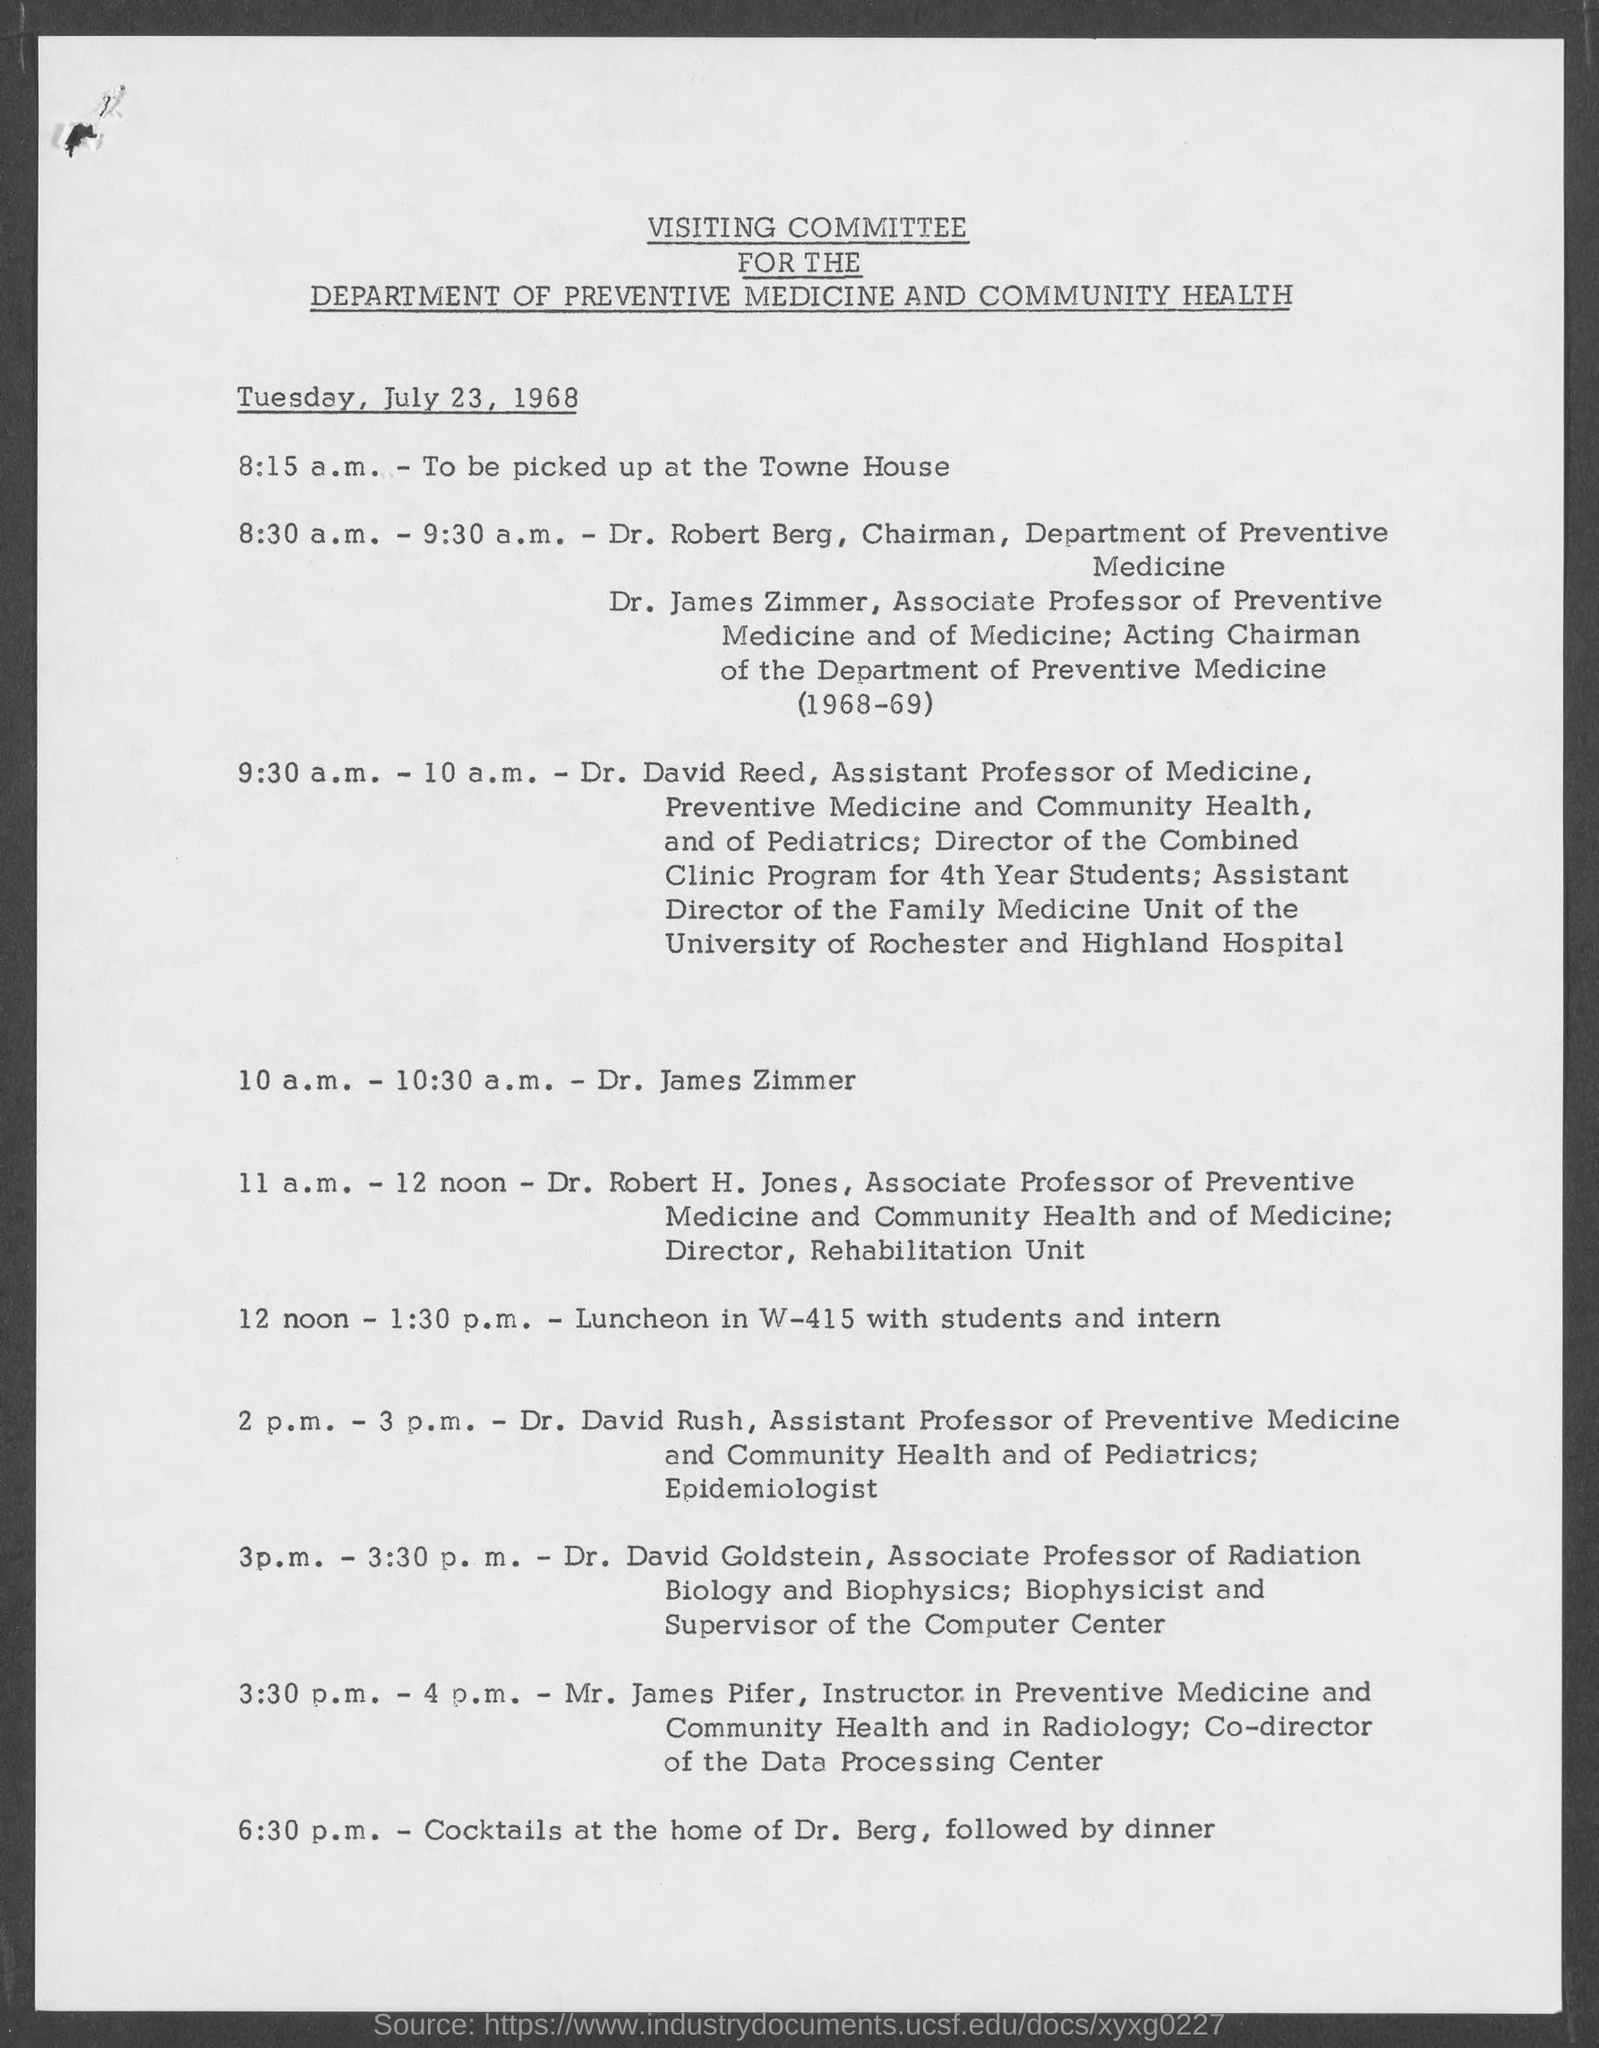What is the name of the Department?
Make the answer very short. Department of preventive medicine and community health. Who is the Chairman of Department of Preventive Medicine?
Your response must be concise. Dr. Robert Berg. 